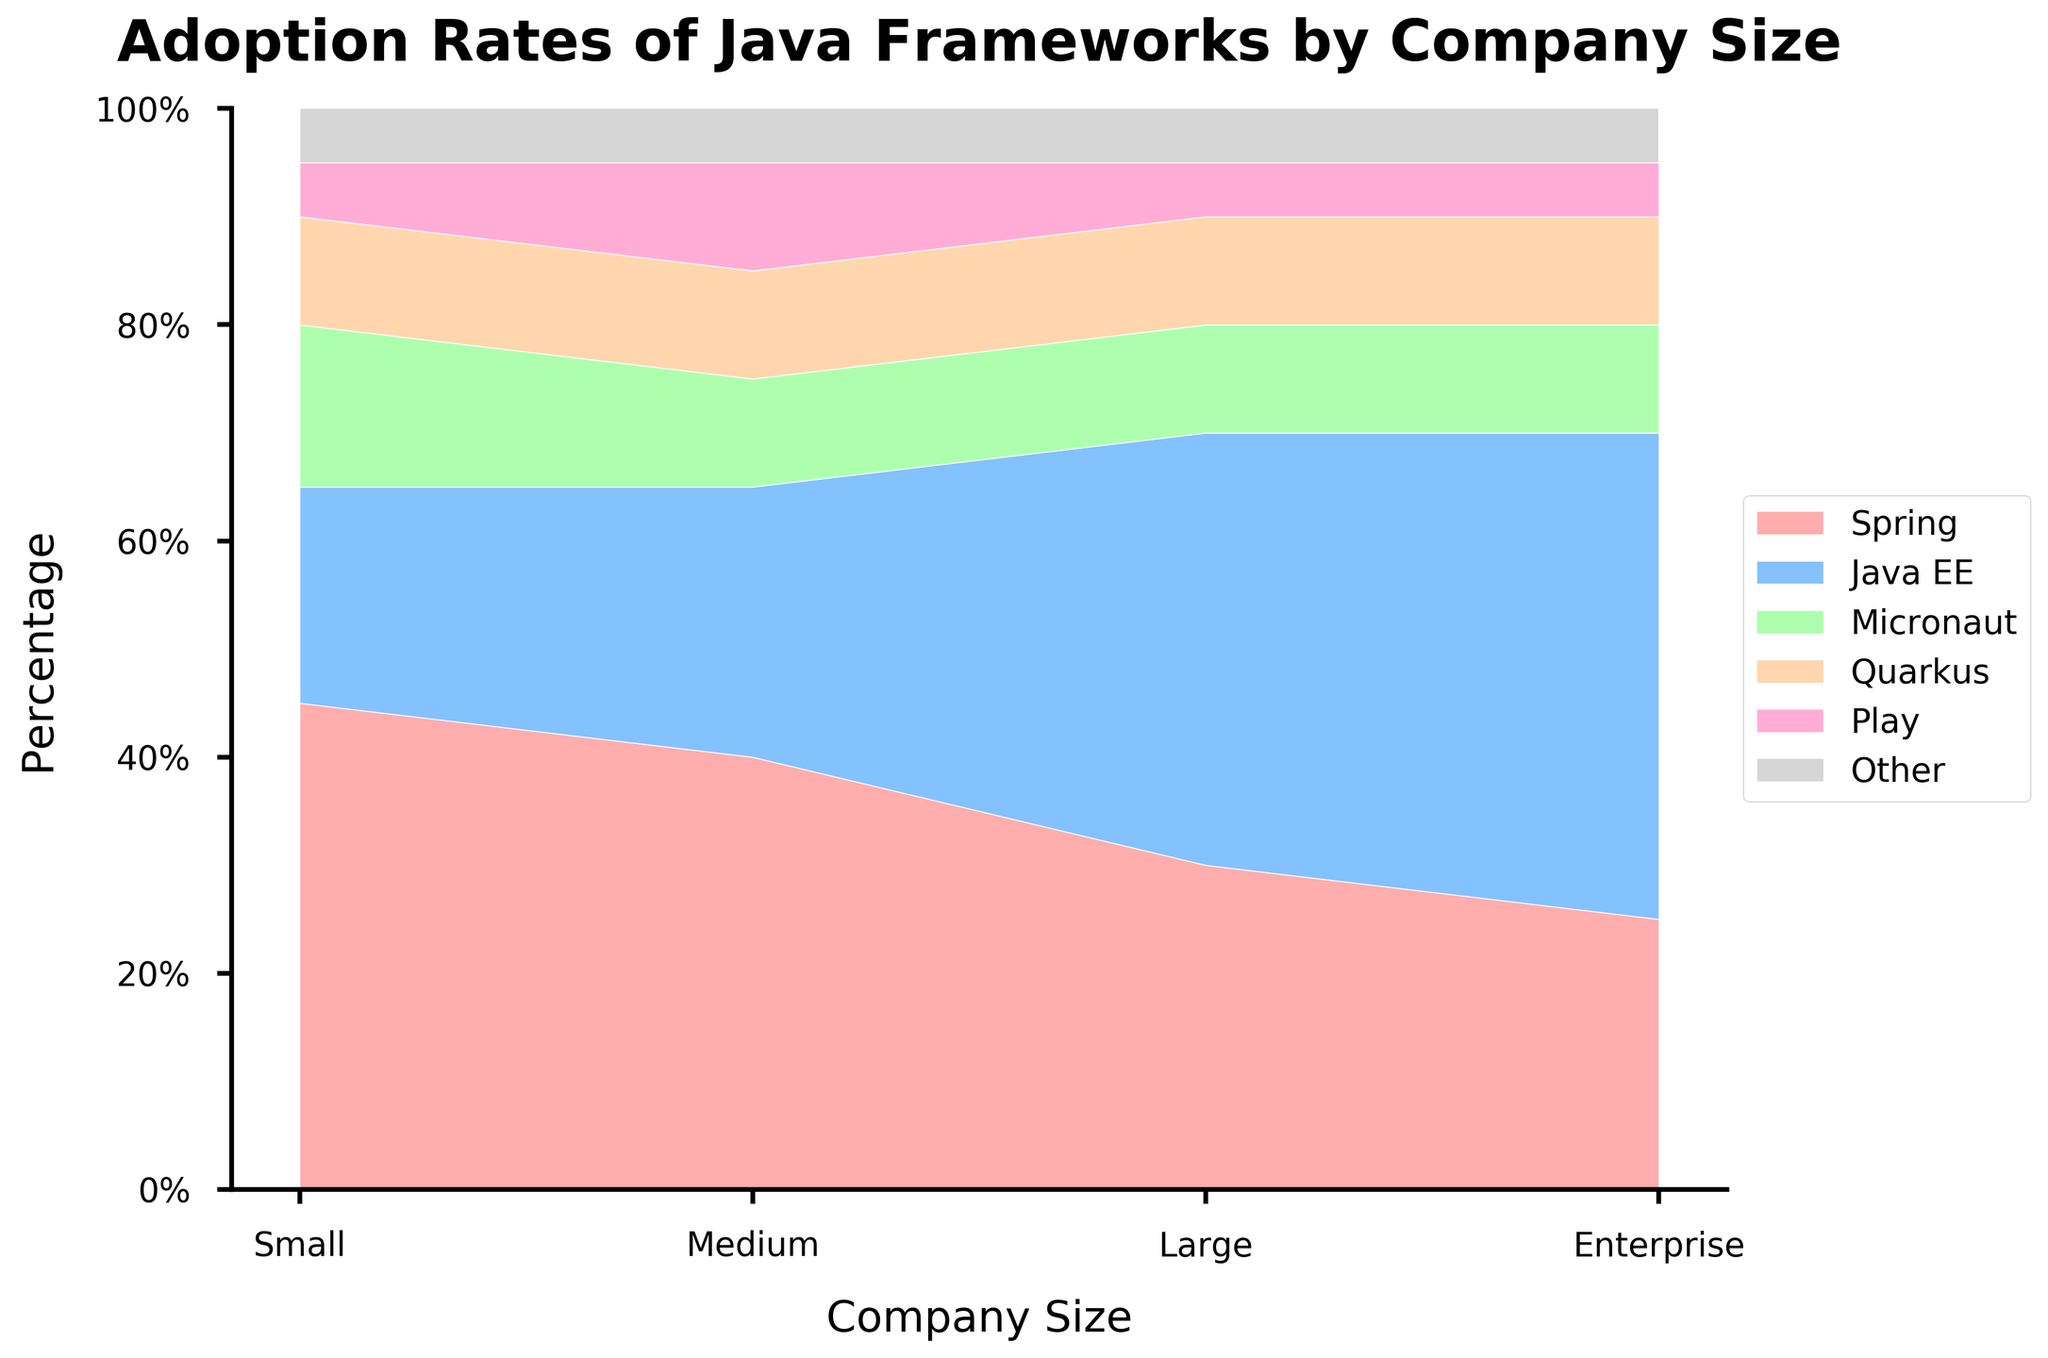What is the title of the figure? The title is typically found at the top of the chart and is meant to give a brief overview of the contents being visualized. In this case, it reads "Adoption Rates of Java Frameworks by Company Size".
Answer: Adoption Rates of Java Frameworks by Company Size What is the percentage of Spring usage in small companies? To find this, look at the area corresponding to "Spring" for small companies on the leftmost section of the chart. The percentage is indicated by the height of the colored region for "Spring".
Answer: 45% Which Java framework has the highest adoption rate in enterprise companies? Each stacked area represents a different Java framework. The framework with the tallest area at the "Enterprise" position on the x-axis is the one with the highest adoption rate.
Answer: Java EE Compare the adoption rates of Spring and Java EE in medium-sized companies. Which one is greater? Locate the "Medium" company size on the x-axis and compare the heights of the colored areas for "Spring" and "Java EE".
Answer: Java EE What is the second most popular Java framework among small companies? For small companies, look at the heights of each colored section within the "Small" category. The second highest section will represent the second most popular framework.
Answer: Java EE How do the adoption rates of Micronaut compare across different company sizes? For each company size (Small, Medium, Large, Enterprise), look at the area corresponding to "Micronaut". Compare the heights visually.
Answer: The rates are similar across all sizes What percentage of large companies use frameworks other than Spring? For large companies, sum the percentages of all frameworks except "Spring". This includes Java EE, Micronaut, Quarkus, Play, and Other.
Answer: 70% Determine the average percentage of Quarkus usage across all company sizes. Locate the "Quarkus" sections for each company size and average their percentages: (10% + 10% + 10% + 10%) / 4.
Answer: 10% What is the difference in the adoption rates of Java EE between medium-sized companies and enterprise companies? Find the "Java EE" sections for medium and enterprise companies and subtract the medium percentage from the enterprise percentage.
Answer: 20% How does the overall trend of Play framework usage look across different company sizes? Identify the areas corresponding to "Play" and observe the trend from left (Small) to right (Enterprise) on the x-axis.
Answer: Steady across all company sizes 